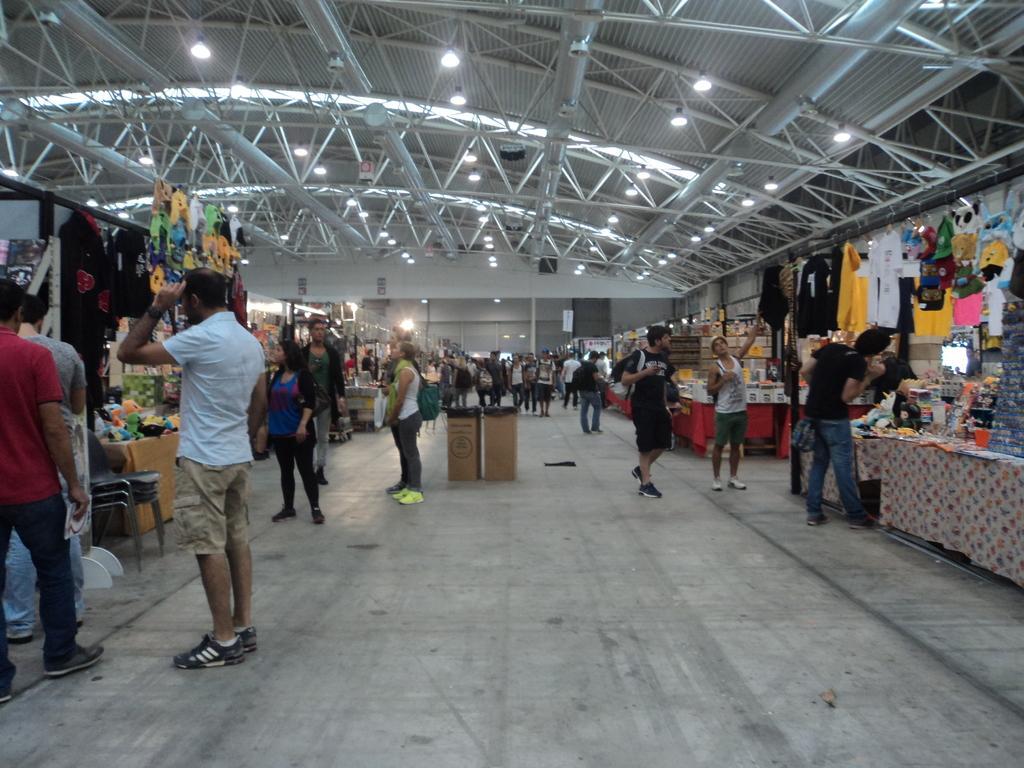Please provide a concise description of this image. In this image there is a big hall. In the image there are lights and iron poles at the top. In the middle there are few people walking on the road. There are shops on either side of the image and there are few people standing near the shops and seeing the items. 